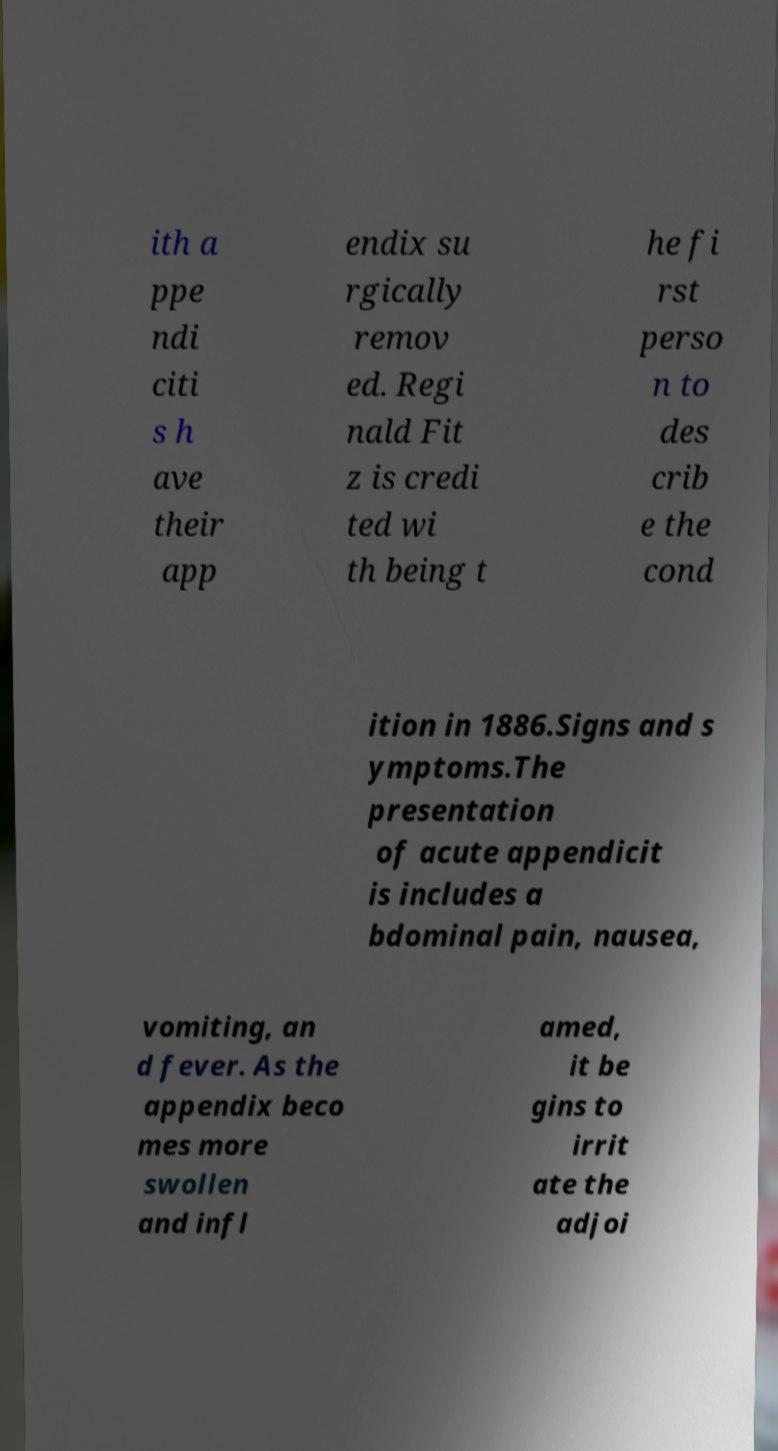Could you extract and type out the text from this image? ith a ppe ndi citi s h ave their app endix su rgically remov ed. Regi nald Fit z is credi ted wi th being t he fi rst perso n to des crib e the cond ition in 1886.Signs and s ymptoms.The presentation of acute appendicit is includes a bdominal pain, nausea, vomiting, an d fever. As the appendix beco mes more swollen and infl amed, it be gins to irrit ate the adjoi 